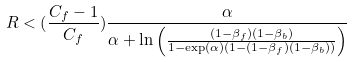<formula> <loc_0><loc_0><loc_500><loc_500>R < ( \frac { C _ { f } - 1 } { C _ { f } } ) \frac { \alpha } { \alpha + \ln \left ( \frac { ( 1 - \beta _ { f } ) ( 1 - \beta _ { b } ) } { 1 - \exp ( \alpha ) ( 1 - ( 1 - \beta _ { f } ) ( 1 - \beta _ { b } ) ) } \right ) }</formula> 